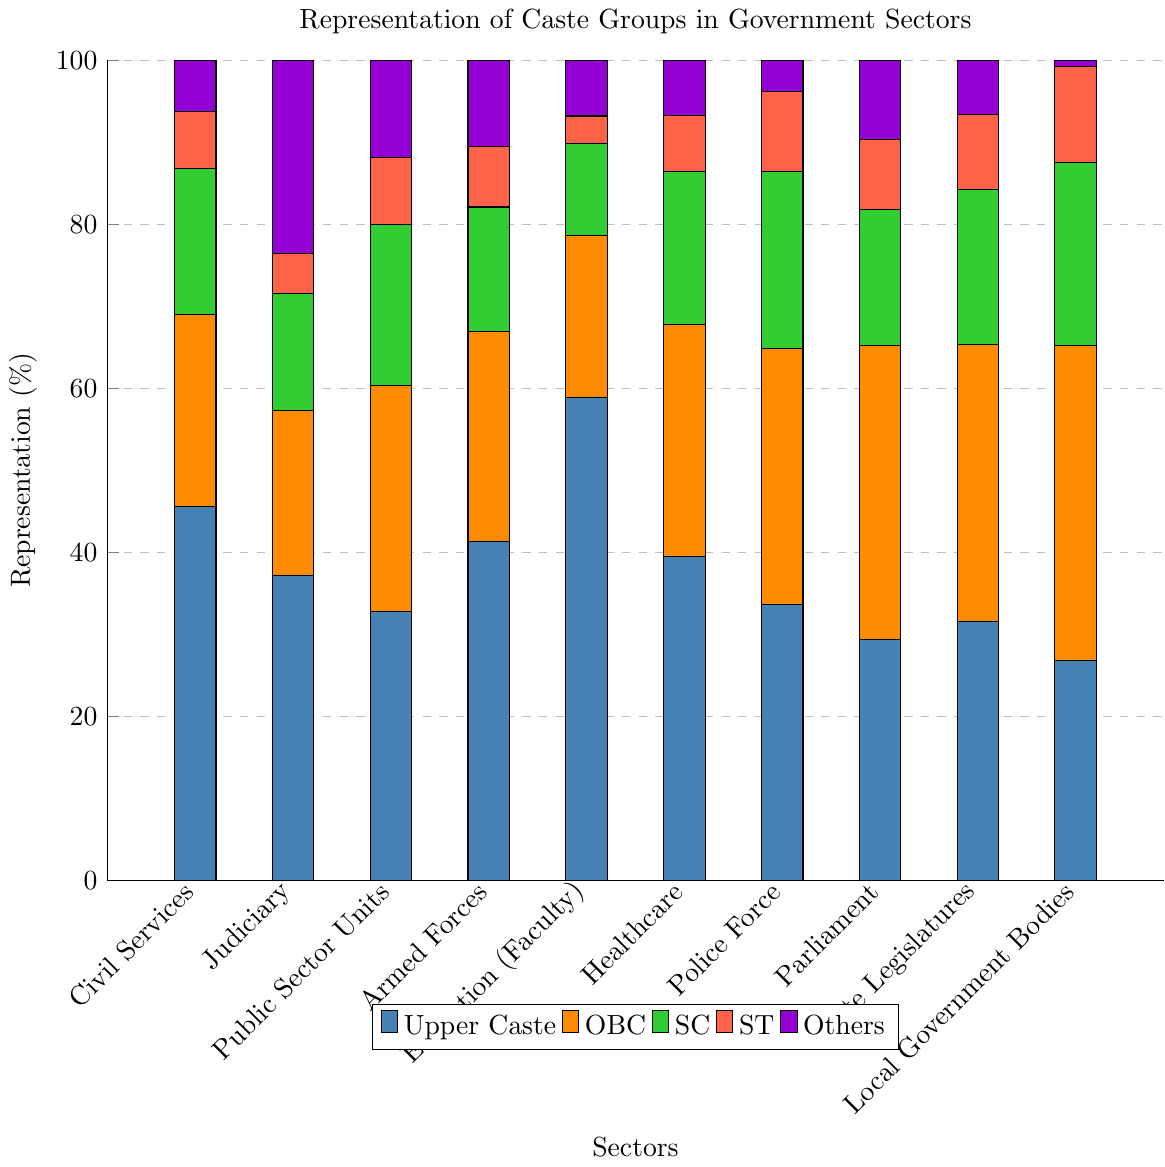What sector has the highest representation of Upper Caste individuals? By examining the figure, the bar representing Upper Caste individuals in the Education (Faculty) sector is the tallest.
Answer: Education (Faculty) Which caste group has the highest representation in Local Government Bodies? The graph shows the color-coded representation of each caste group. The color representing OBC has the highest bar in the Local Government Bodies sector.
Answer: OBC How does the representation of SC compare between Civil Services and Judiciary? By observing the SC bars in Civil Services and Judiciary sectors, the SC representation in the Civil Services sector (17.8%) is higher than in the Judiciary sector (14.3%).
Answer: Civil Services > Judiciary What is the combined representation percentage of ST and Others in the Armed Forces sector? The bars for ST and Others in the Armed Forces show percentages of 7.4% and 10.5%, respectively. Adding them together gives 7.4 + 10.5 = 17.9%.
Answer: 17.9% Which sector has the lowest representation of ST individuals? The smallest ST bar must be located. The Education (Faculty) sector has the smallest bar at 3.4%.
Answer: Education (Faculty) What is the difference in OBC representation between Parliament and Public Sector Units? The heights of the OBC bars in Parliament (35.8%) and Public Sector Units (27.5%) need to be compared. Subtracting 27.5 from 35.8 gives 35.8 - 27.5 = 8.3%.
Answer: 8.3% How does the total representation of Upper Caste and OBC individuals in Healthcare compare to their combined representation in Police Force? In Healthcare, Upper Caste is 39.5% and OBC is 28.3%, summing these is 39.5 + 28.3 = 67.8%. In Police Force, Upper Caste is 33.7% and OBC is 31.2%, summing these is 33.7 + 31.2 = 64.9%. Comparing 67.8% to 64.9%, Healthcare is higher.
Answer: Healthcare > Police Force Which sector has the most balanced distribution among all caste groups? By examining each sector's bars for uniformity in height, the most balanced distribution is in Police Force, where the bar heights are relatively similar compared to other sectors.
Answer: Police Force What is the average representation of Others across all sectors? Summing the representation percentages of Others across all sectors: 6.3 + 23.6 + 11.9 + 10.5 + 6.8 + 6.7 + 3.8 + 9.7 + 6.6 + 0.8 gives a total of 86.7. Dividing by the number of sectors, 86.7 / 10 = 8.67%.
Answer: 8.67% In which sector is the representation of OBC individuals closest to the representation of Upper Caste individuals? By comparing the OBC and Upper Caste bars in each sector, the Local Government Bodies sector has the closest values, OBC at 38.4% and Upper Caste at 26.8%, giving a difference of 38.4% - 26.8% = 11.6%.
Answer: Local Government Bodies 